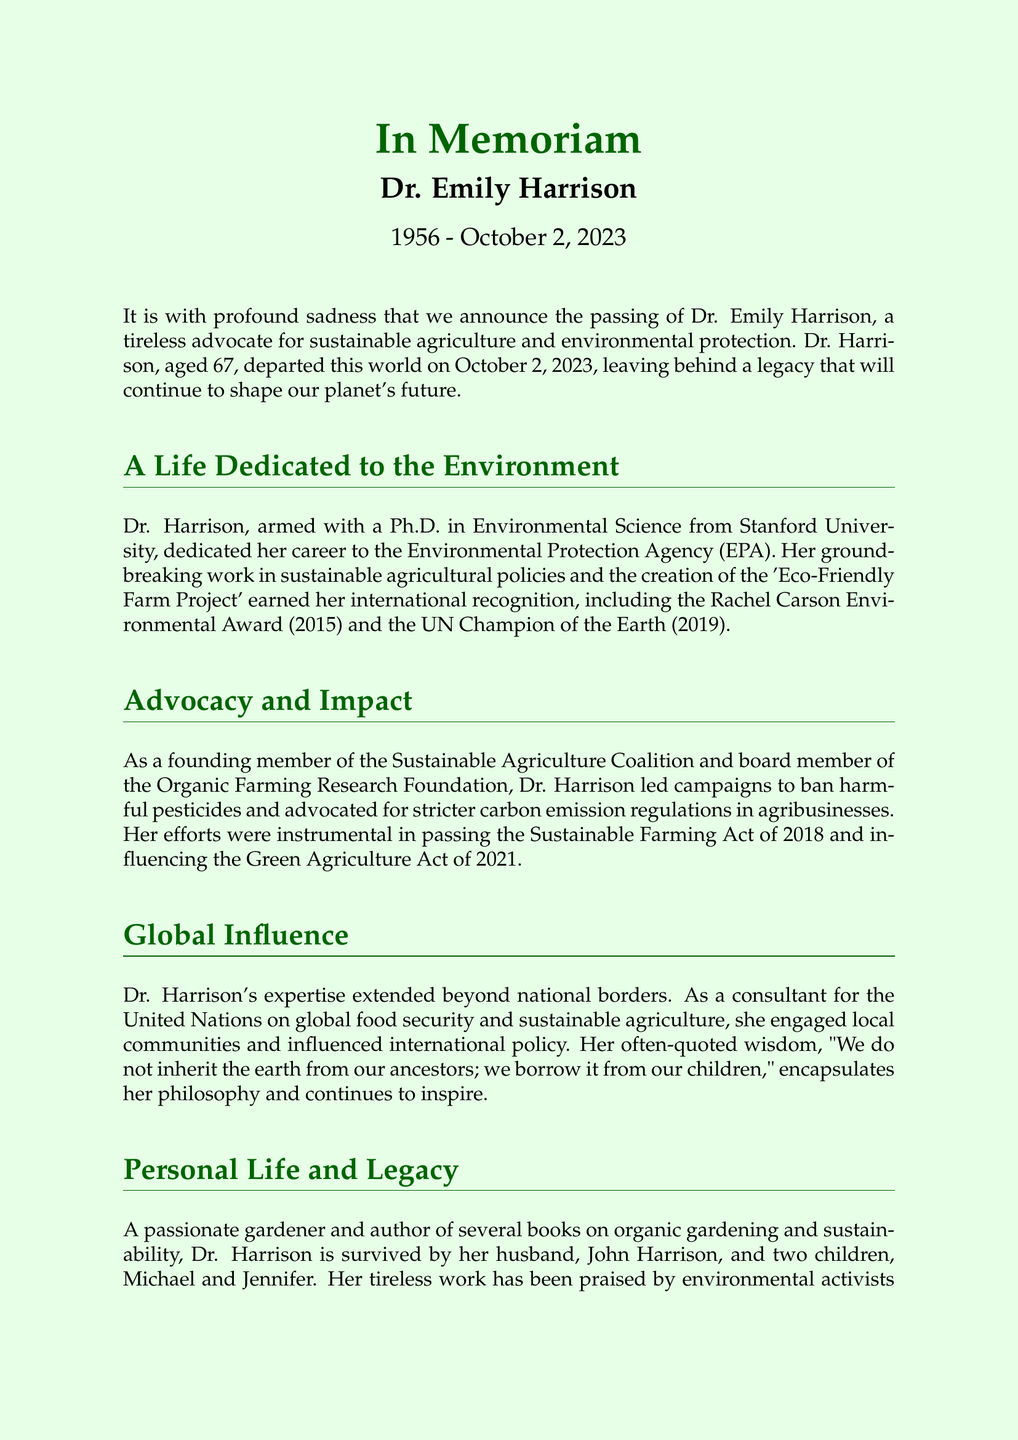What year did Dr. Emily Harrison receive the Rachel Carson Environmental Award? The document states that Dr. Harrison received the Rachel Carson Environmental Award in 2015.
Answer: 2015 What organization did Dr. Harrison help to found? The document mentions that Dr. Harrison was a founding member of the Sustainable Agriculture Coalition.
Answer: Sustainable Agriculture Coalition What was the title of Dr. Harrison's project recognized internationally? The document describes her project as the 'Eco-Friendly Farm Project'.
Answer: Eco-Friendly Farm Project How old was Dr. Harrison at the time of her passing? The obituary states that Dr. Harrison was 67 years old when she passed away.
Answer: 67 Which act did Dr. Harrison contribute to passing in 2018? The document specifies that Dr. Harrison's efforts were instrumental in passing the Sustainable Farming Act of 2018.
Answer: Sustainable Farming Act of 2018 Why is Dr. Harrison considered a visionary leader? The document describes her as a visionary leader in sustainable agriculture due to her impactful advocacy work and campaigns.
Answer: Impactful advocacy work What did Dr. Harrison often quote about inheritance and the Earth? According to the document, Dr. Harrison often quoted, "We do not inherit the earth from our ancestors; we borrow it from our children."
Answer: We do not inherit the earth from our ancestors; we borrow it from our children Who survived Dr. Emily Harrison? The document states that she is survived by her husband, John Harrison, and two children, Michael and Jennifer.
Answer: John Harrison, Michael, and Jennifer 